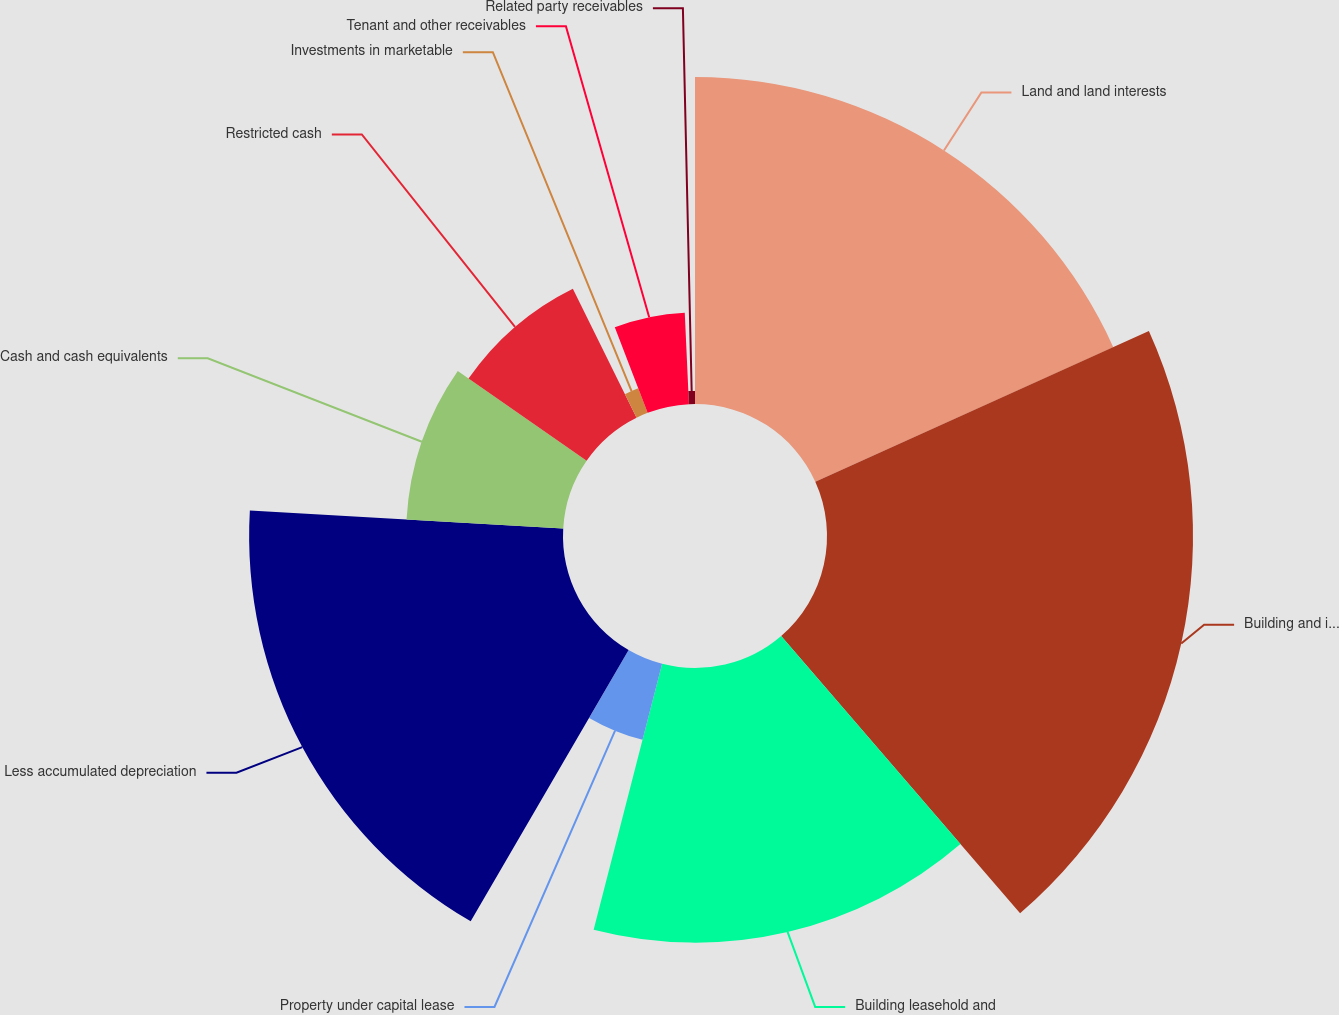Convert chart. <chart><loc_0><loc_0><loc_500><loc_500><pie_chart><fcel>Land and land interests<fcel>Building and improvements<fcel>Building leasehold and<fcel>Property under capital lease<fcel>Less accumulated depreciation<fcel>Cash and cash equivalents<fcel>Restricted cash<fcel>Investments in marketable<fcel>Tenant and other receivables<fcel>Related party receivables<nl><fcel>18.25%<fcel>20.43%<fcel>15.33%<fcel>4.38%<fcel>17.52%<fcel>8.76%<fcel>8.03%<fcel>1.46%<fcel>5.11%<fcel>0.73%<nl></chart> 